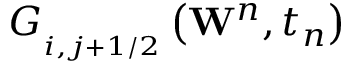<formula> <loc_0><loc_0><loc_500><loc_500>G _ { _ { i , j + 1 / 2 } } \left ( { { W } ^ { n } } , { { t } _ { n } } \right )</formula> 